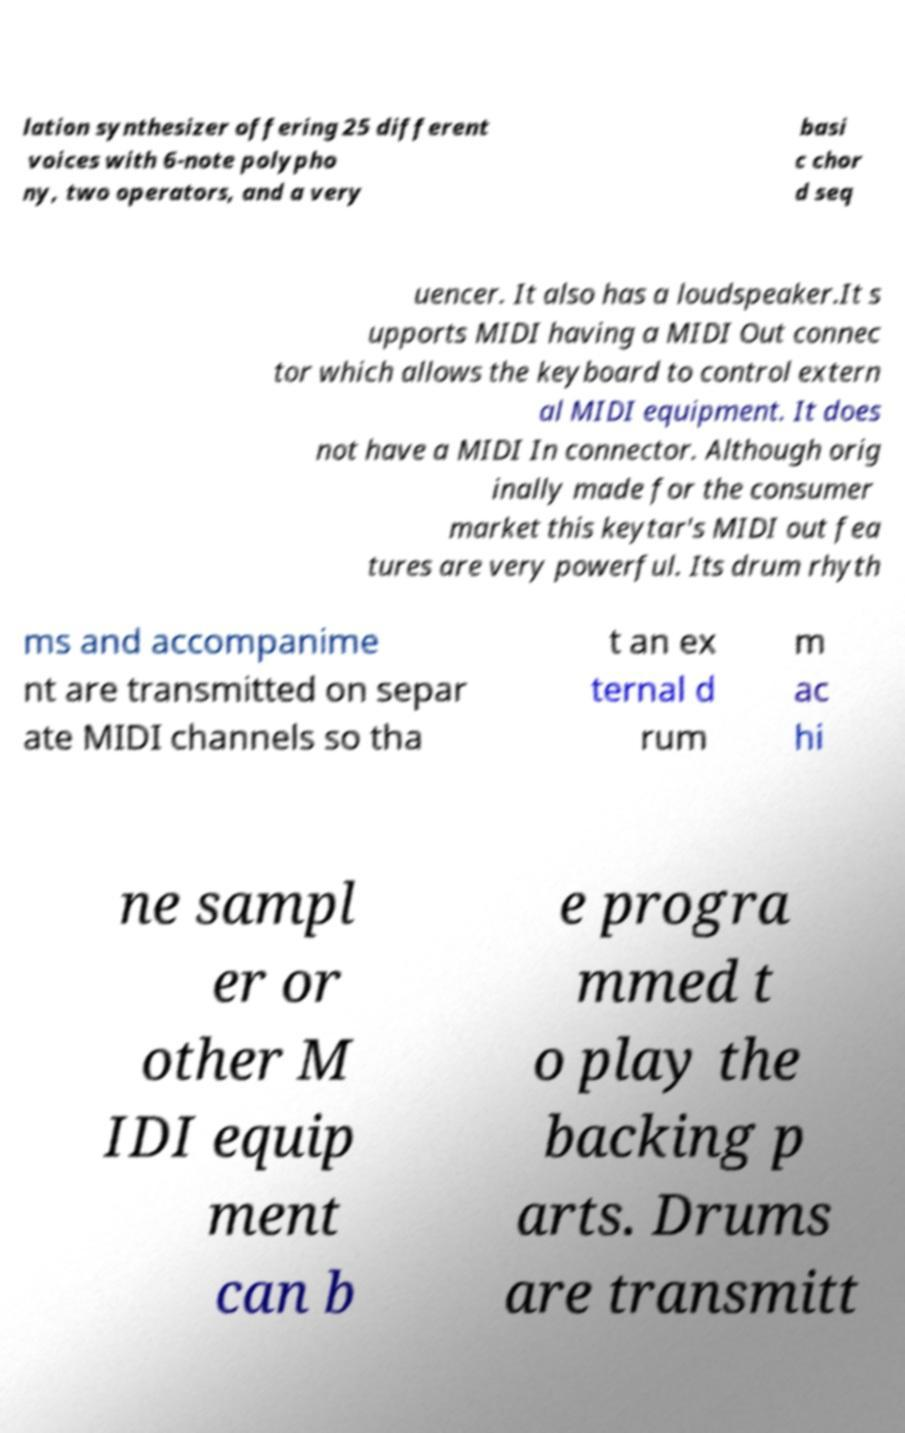What messages or text are displayed in this image? I need them in a readable, typed format. lation synthesizer offering 25 different voices with 6-note polypho ny, two operators, and a very basi c chor d seq uencer. It also has a loudspeaker.It s upports MIDI having a MIDI Out connec tor which allows the keyboard to control extern al MIDI equipment. It does not have a MIDI In connector. Although orig inally made for the consumer market this keytar's MIDI out fea tures are very powerful. Its drum rhyth ms and accompanime nt are transmitted on separ ate MIDI channels so tha t an ex ternal d rum m ac hi ne sampl er or other M IDI equip ment can b e progra mmed t o play the backing p arts. Drums are transmitt 